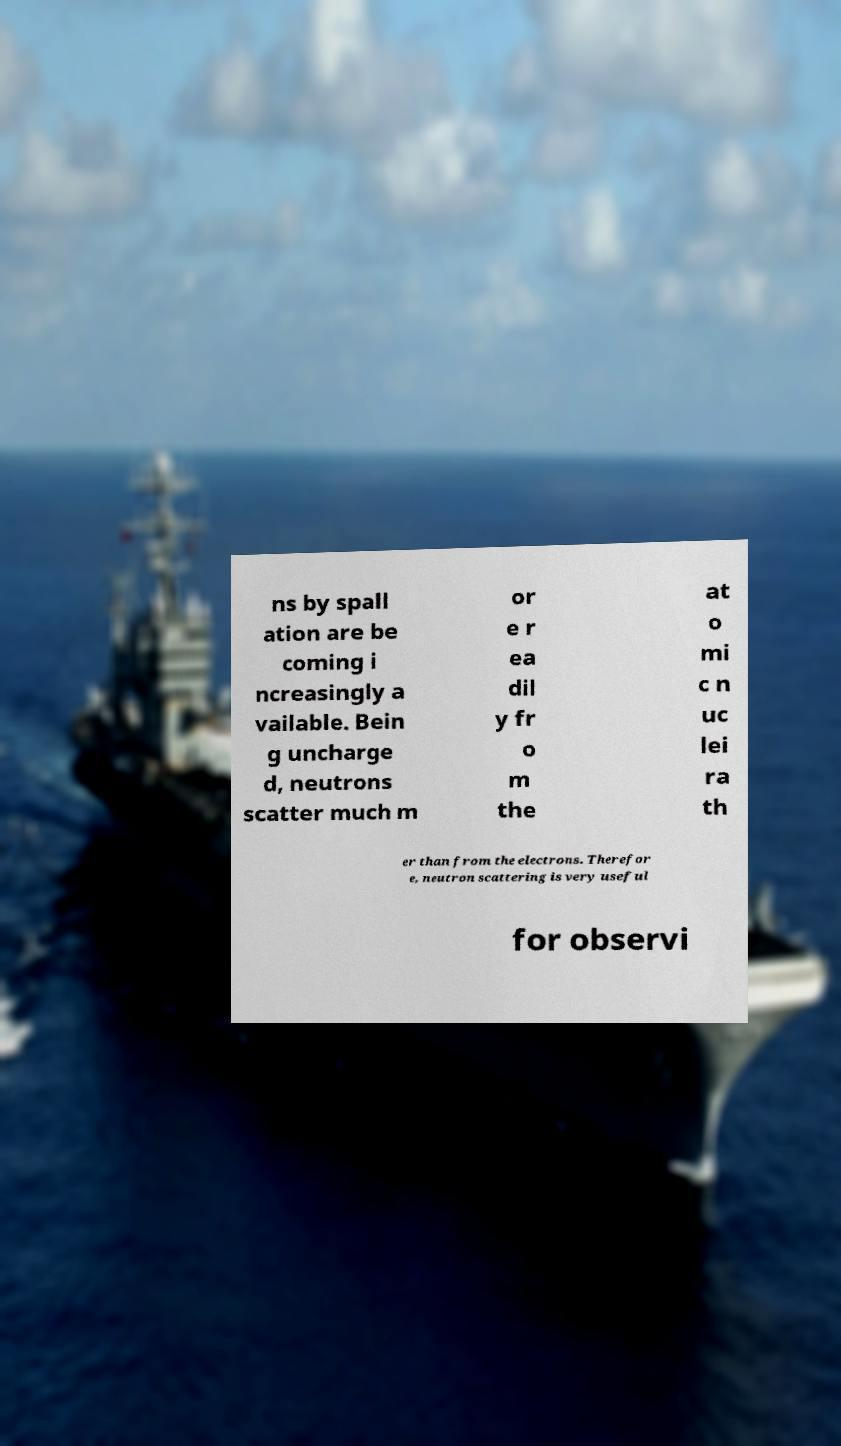Can you accurately transcribe the text from the provided image for me? ns by spall ation are be coming i ncreasingly a vailable. Bein g uncharge d, neutrons scatter much m or e r ea dil y fr o m the at o mi c n uc lei ra th er than from the electrons. Therefor e, neutron scattering is very useful for observi 